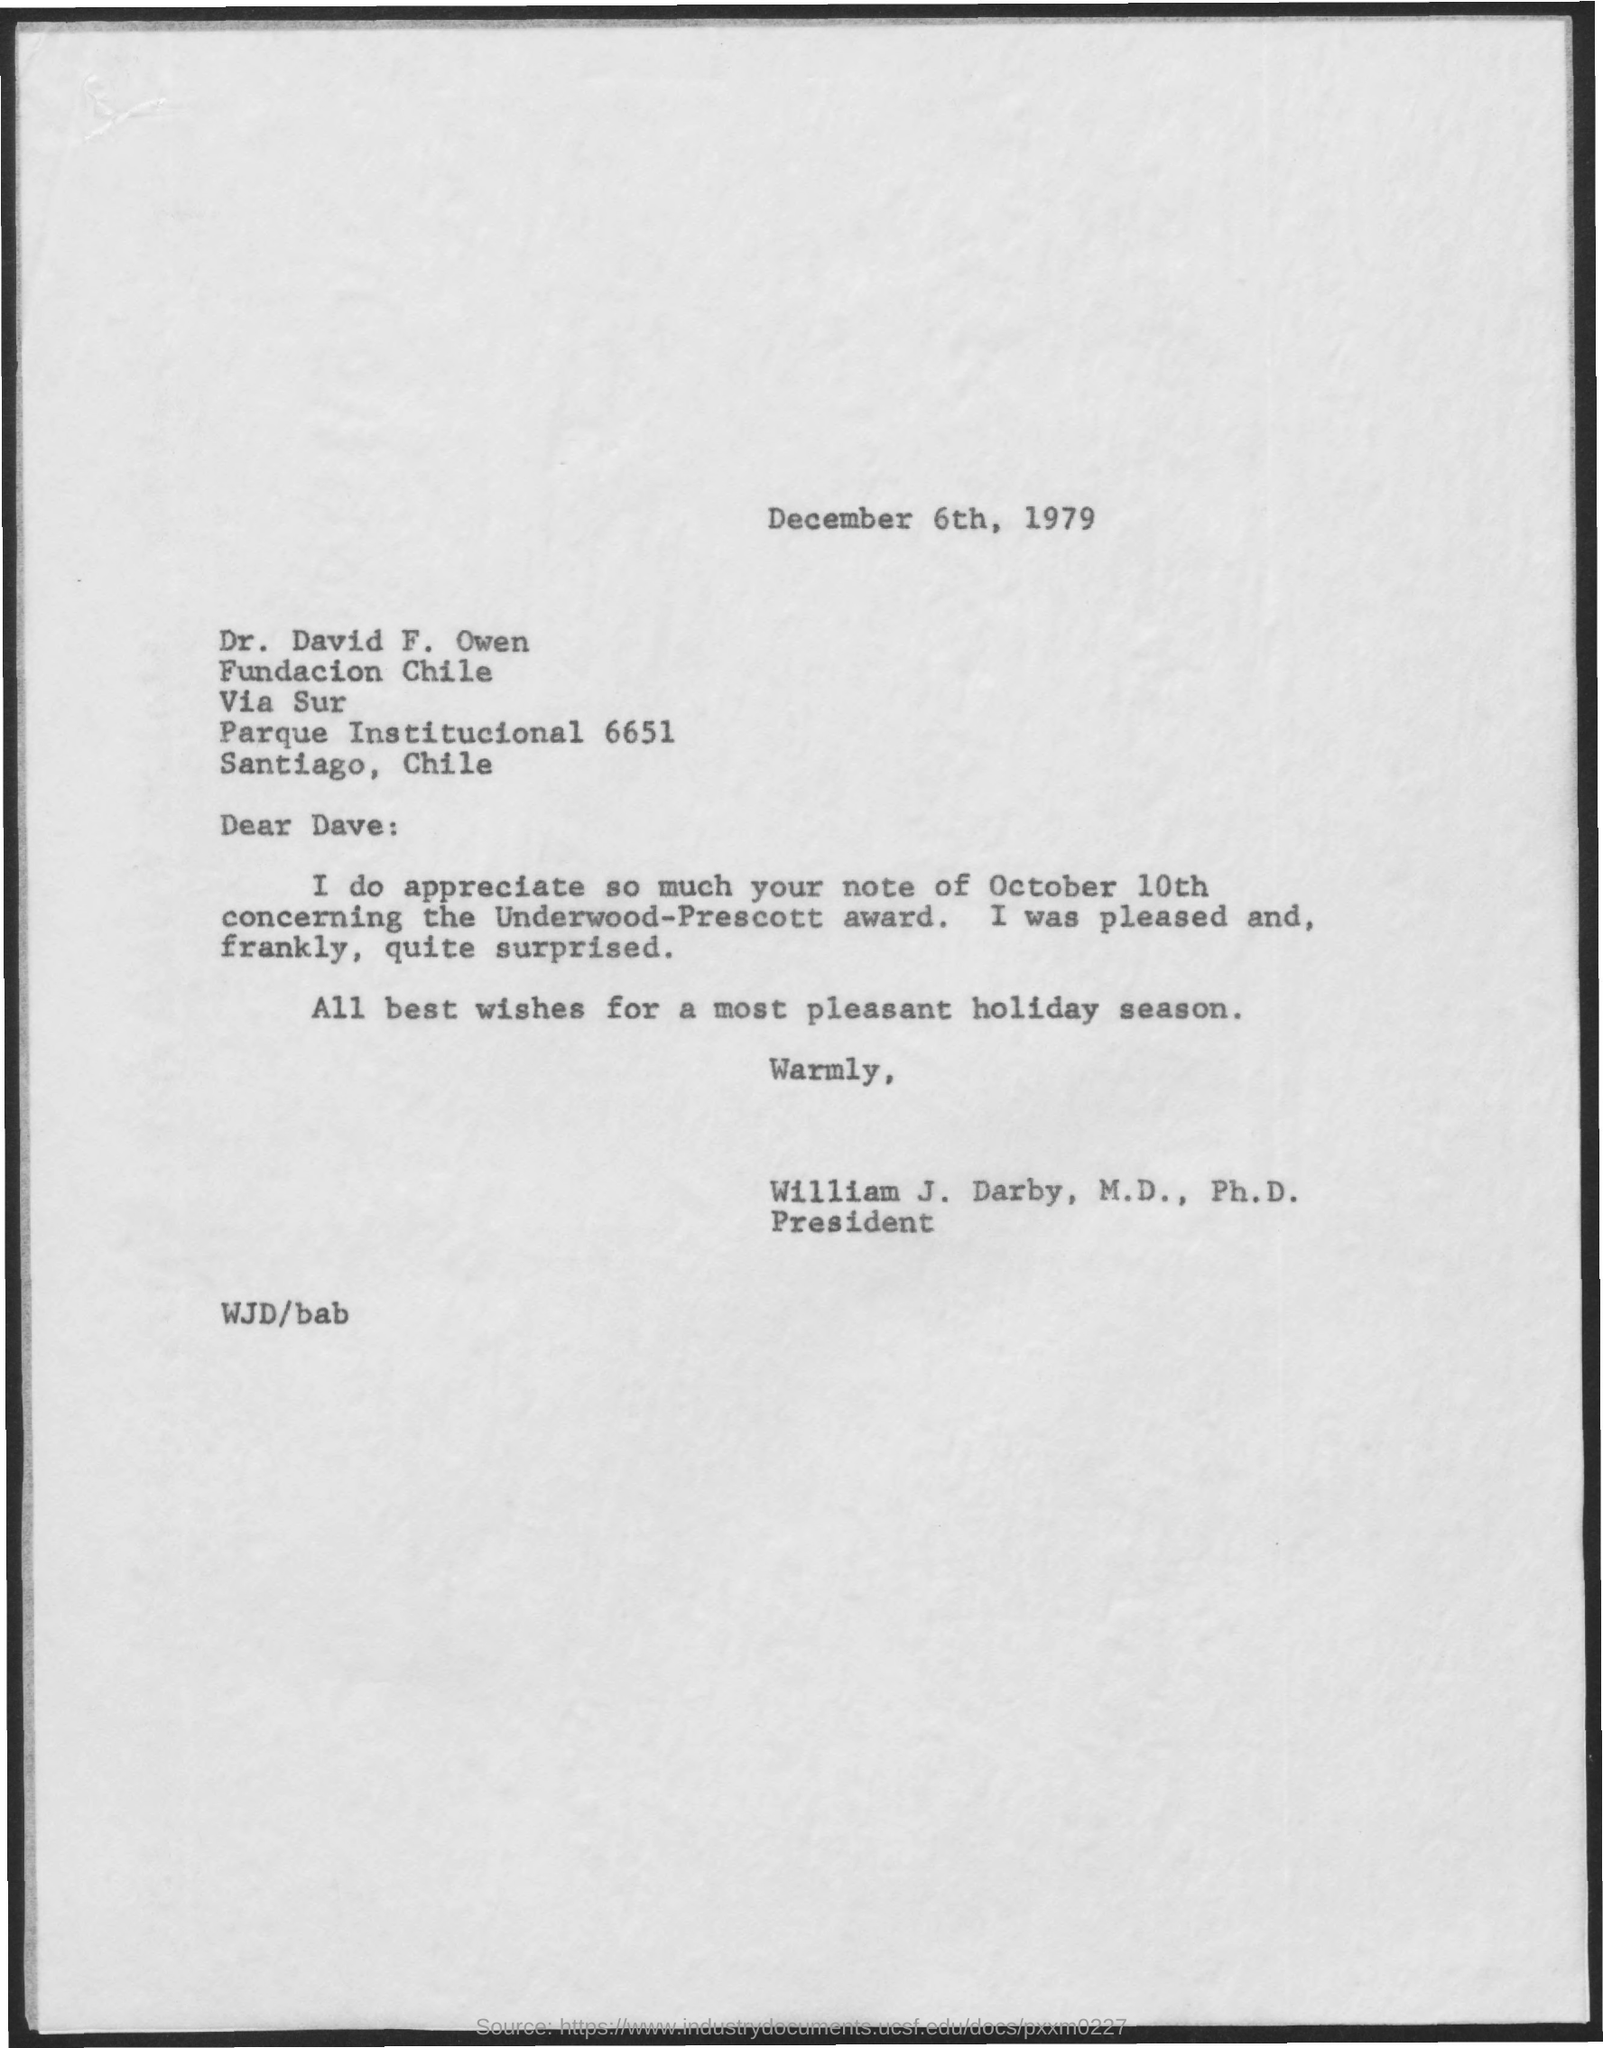Mention a couple of crucial points in this snapshot. William J. Darby has been designated as the president. The date mentioned in the given page is December 6th, 1979. 